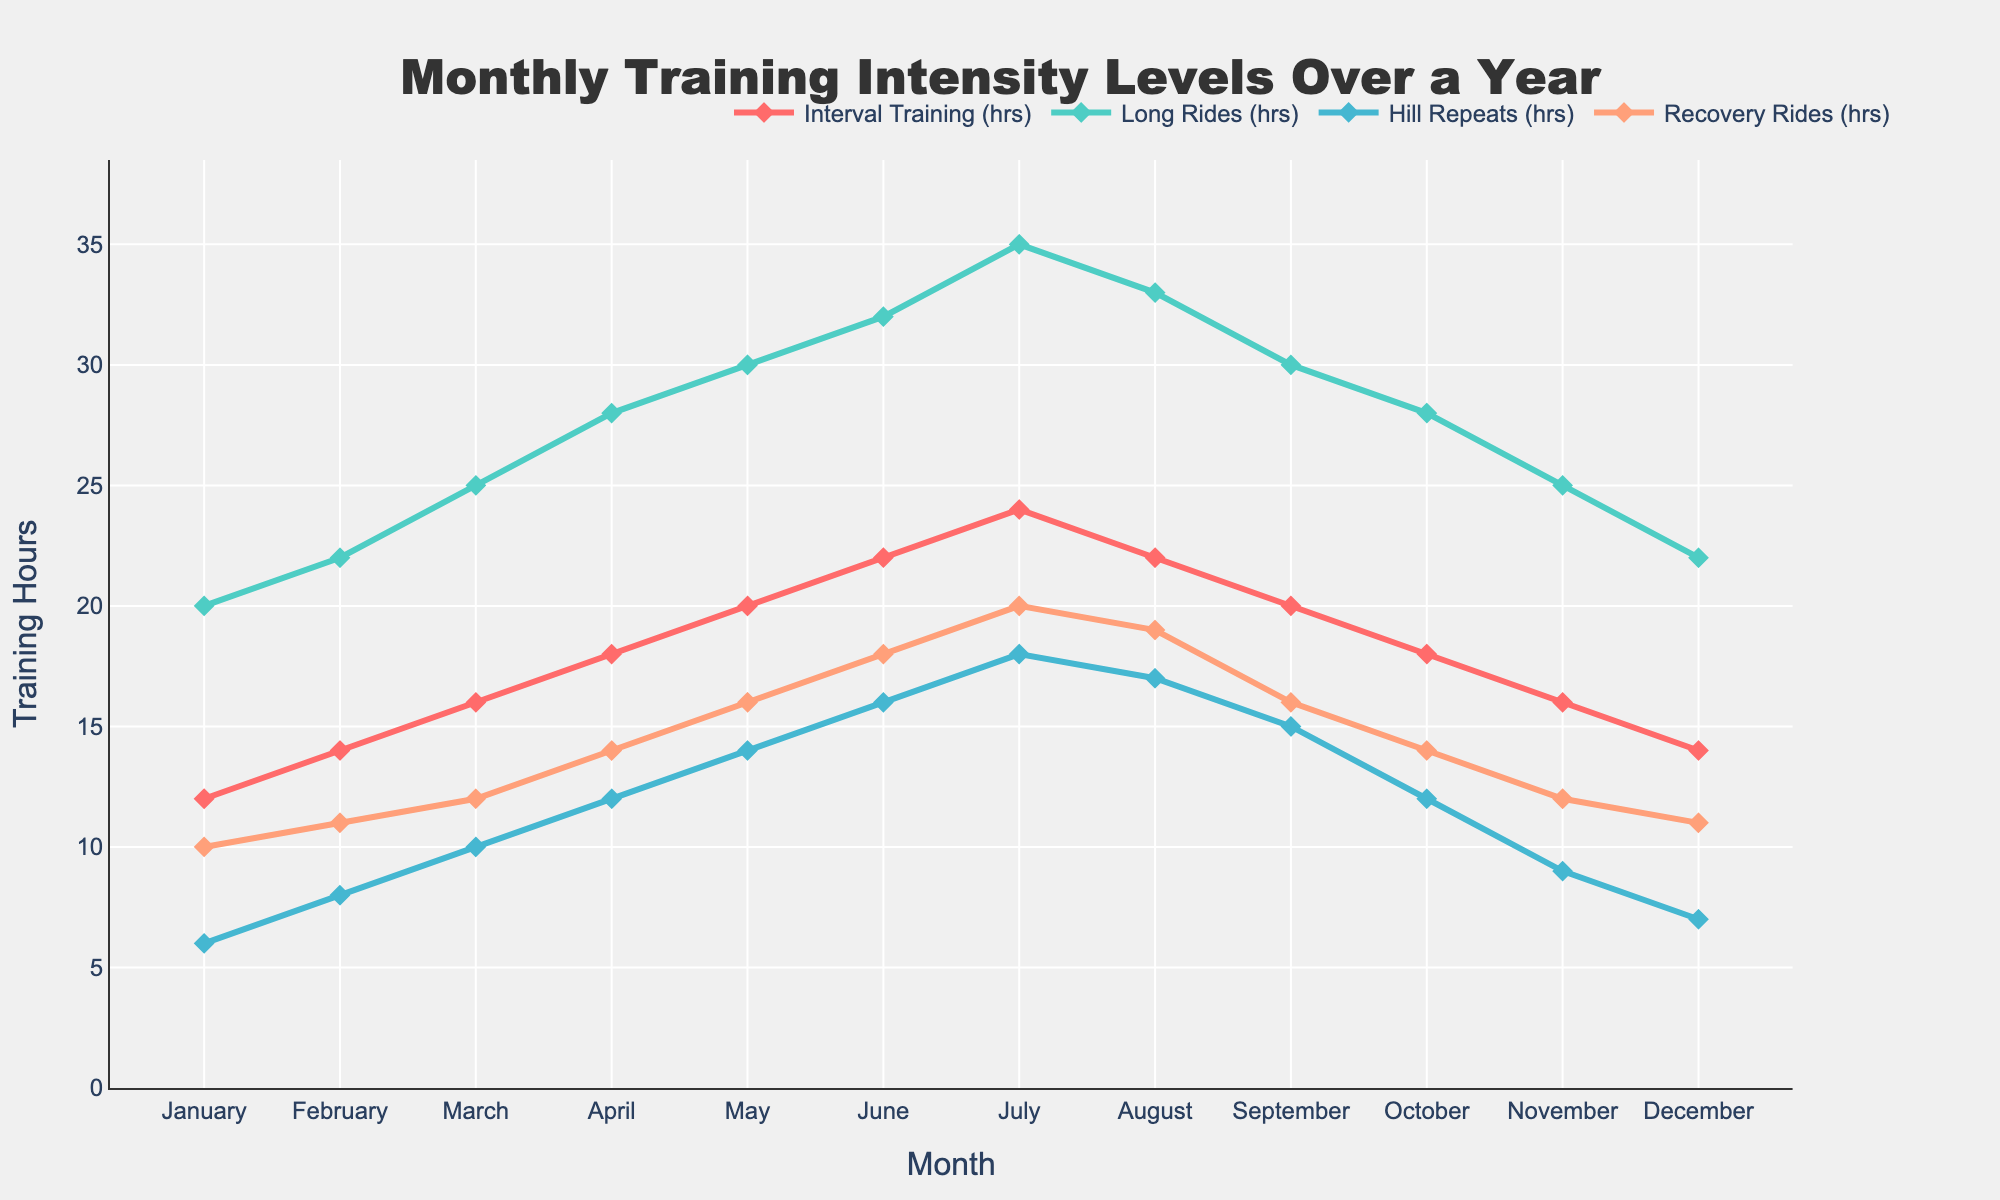what is the title of the figure? The title of the figure is written at the top center of the plot. It is often in larger and bold text to draw attention. By reading it, we can understand the overall subject of the chart.
Answer: Monthly Training Intensity Levels Over a Year How many training hours did Interval Training have in July? To find this, we look for the July data point within the Interval Training series, typically represented by a specific line or marker.
Answer: 24 Which month had the highest total training hours combining all types of rides? To answer this, we need to compute the sum of all types of rides for each month and then identify the month with the highest sum. For July, Interval Training (24) + Long Rides (35) + Hill Repeats (18) + Recovery Rides (20) = 97, which is the maximum.
Answer: July How did the training hours for Hill Repeats change from March to April? We need to find the training hours for Hill Repeats in March and April and calculate the difference. March had 10 hours, and April had 12 hours, so the change is 12 - 10 = 2 hours.
Answer: Increased by 2 hours What is the average number of Recovery Rides hours over the year? To find the average, sum up the Recovery Rides hours for each month and divide by the number of months (12). The total is 10 + 11 + 12 + 14 + 16 + 18 + 20 + 19 + 16 + 14 + 12 + 11 = 173, so the average is 173 / 12.
Answer: 14.42 hours Between which two consecutive months is there the largest decrease in Long Rides hours? We need to calculate the difference in Long Rides hours between each pair of consecutive months and identify the largest negative difference. The biggest drop is from August to September (33 - 30 = -3).
Answer: August to September What pattern can you observe in the training hours for Interval Training over the year? By examining the Interval Training line chart throughout the months, we can observe a trend in its values. It increases steadily each month until July where it peaks at 24 hours, then slightly decreases towards the end of the year.
Answer: Increasing then decreasing pattern Which type of training had the most stable number of hours throughout the year? To determine the stability, we look for the training type whose hours fluctuate the least across the months by visually comparing their variations in the plot. Recovery Rides show the least fluctuation.
Answer: Recovery Rides What are the training hours for Long Rides in June and how do they compare to February? Find the Long Rides hours for both months and compare them directly. June has 32 hours, and February has 22 hours, so June’s Long Rides are greater by 10 hours.
Answer: June has 10 more hours 